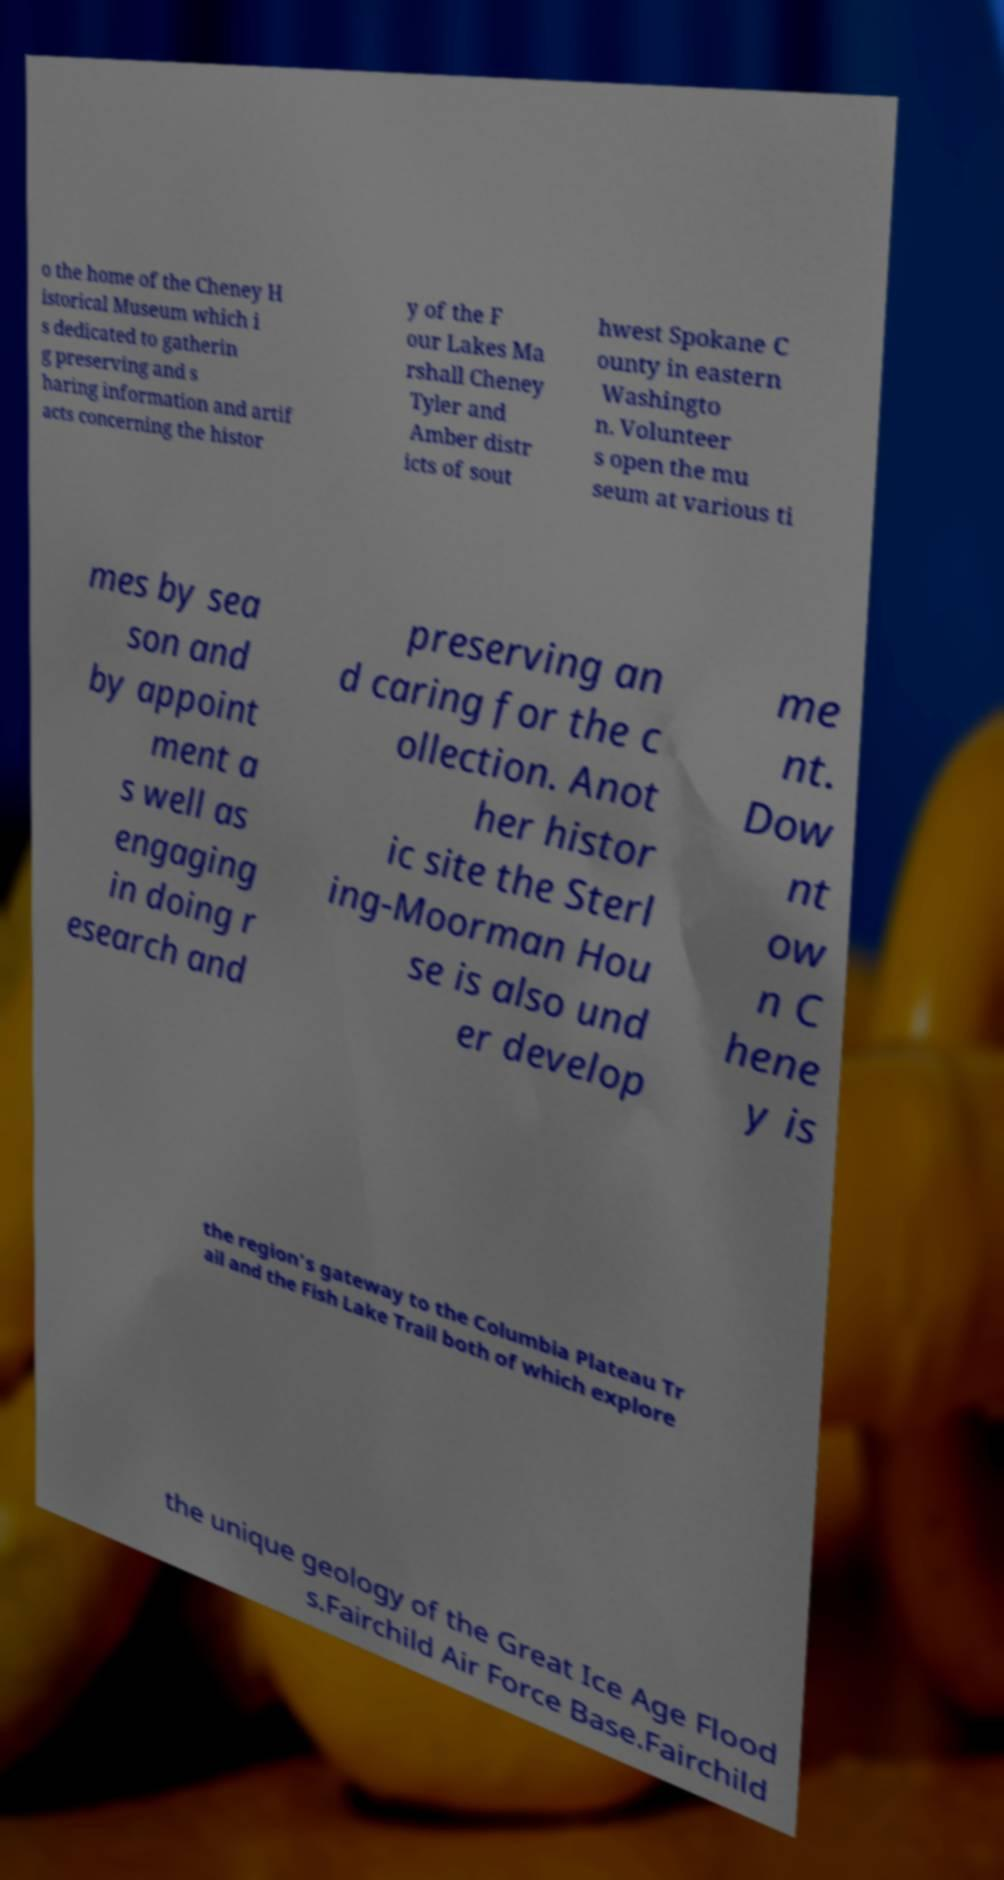There's text embedded in this image that I need extracted. Can you transcribe it verbatim? o the home of the Cheney H istorical Museum which i s dedicated to gatherin g preserving and s haring information and artif acts concerning the histor y of the F our Lakes Ma rshall Cheney Tyler and Amber distr icts of sout hwest Spokane C ounty in eastern Washingto n. Volunteer s open the mu seum at various ti mes by sea son and by appoint ment a s well as engaging in doing r esearch and preserving an d caring for the c ollection. Anot her histor ic site the Sterl ing-Moorman Hou se is also und er develop me nt. Dow nt ow n C hene y is the region's gateway to the Columbia Plateau Tr ail and the Fish Lake Trail both of which explore the unique geology of the Great Ice Age Flood s.Fairchild Air Force Base.Fairchild 